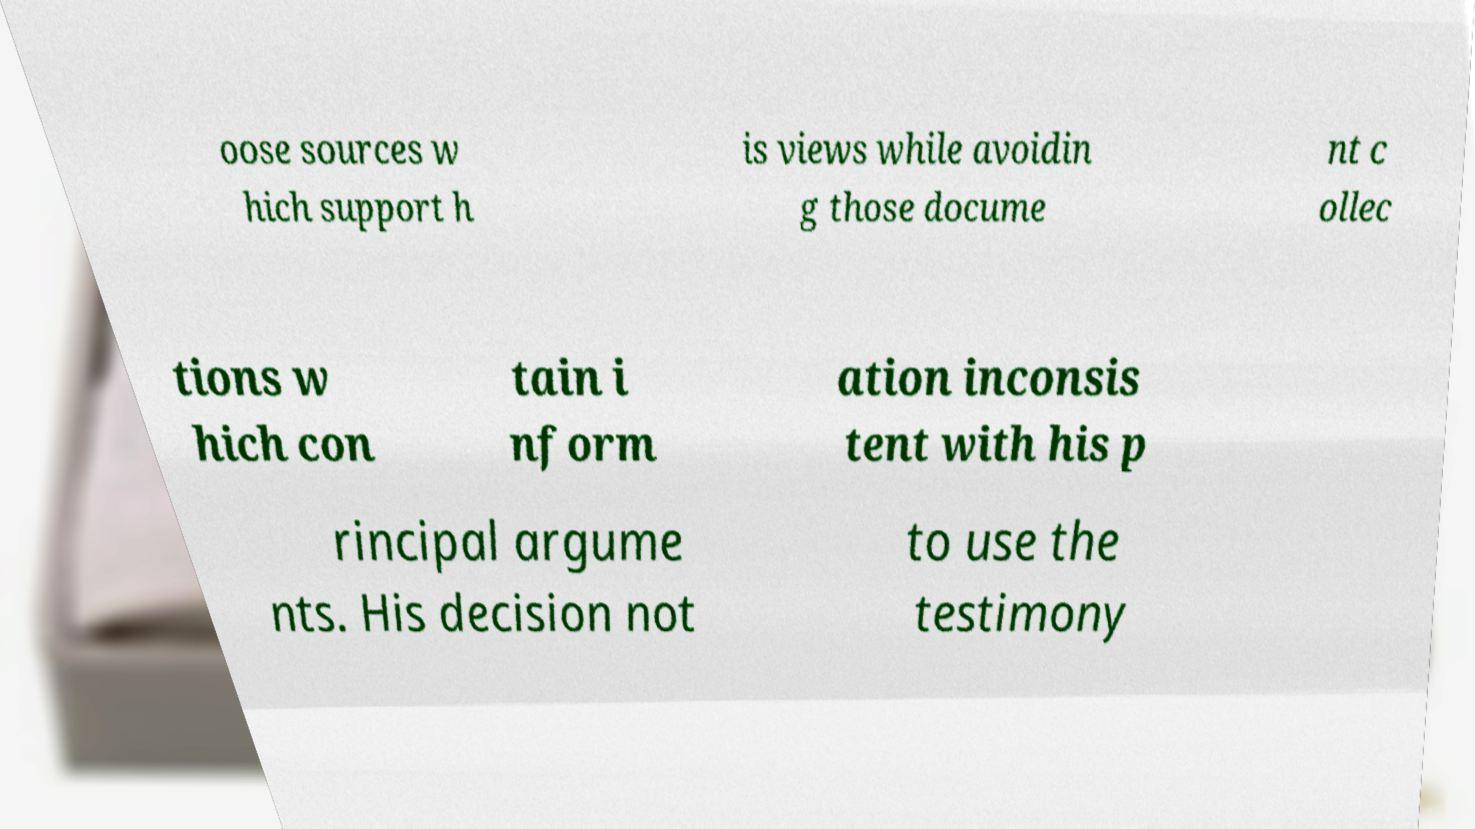Can you accurately transcribe the text from the provided image for me? oose sources w hich support h is views while avoidin g those docume nt c ollec tions w hich con tain i nform ation inconsis tent with his p rincipal argume nts. His decision not to use the testimony 